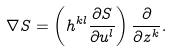<formula> <loc_0><loc_0><loc_500><loc_500>\nabla S = \left ( h ^ { k l } \frac { \partial S } { \partial u ^ { l } } \right ) \frac { \partial } { \partial z ^ { k } } .</formula> 